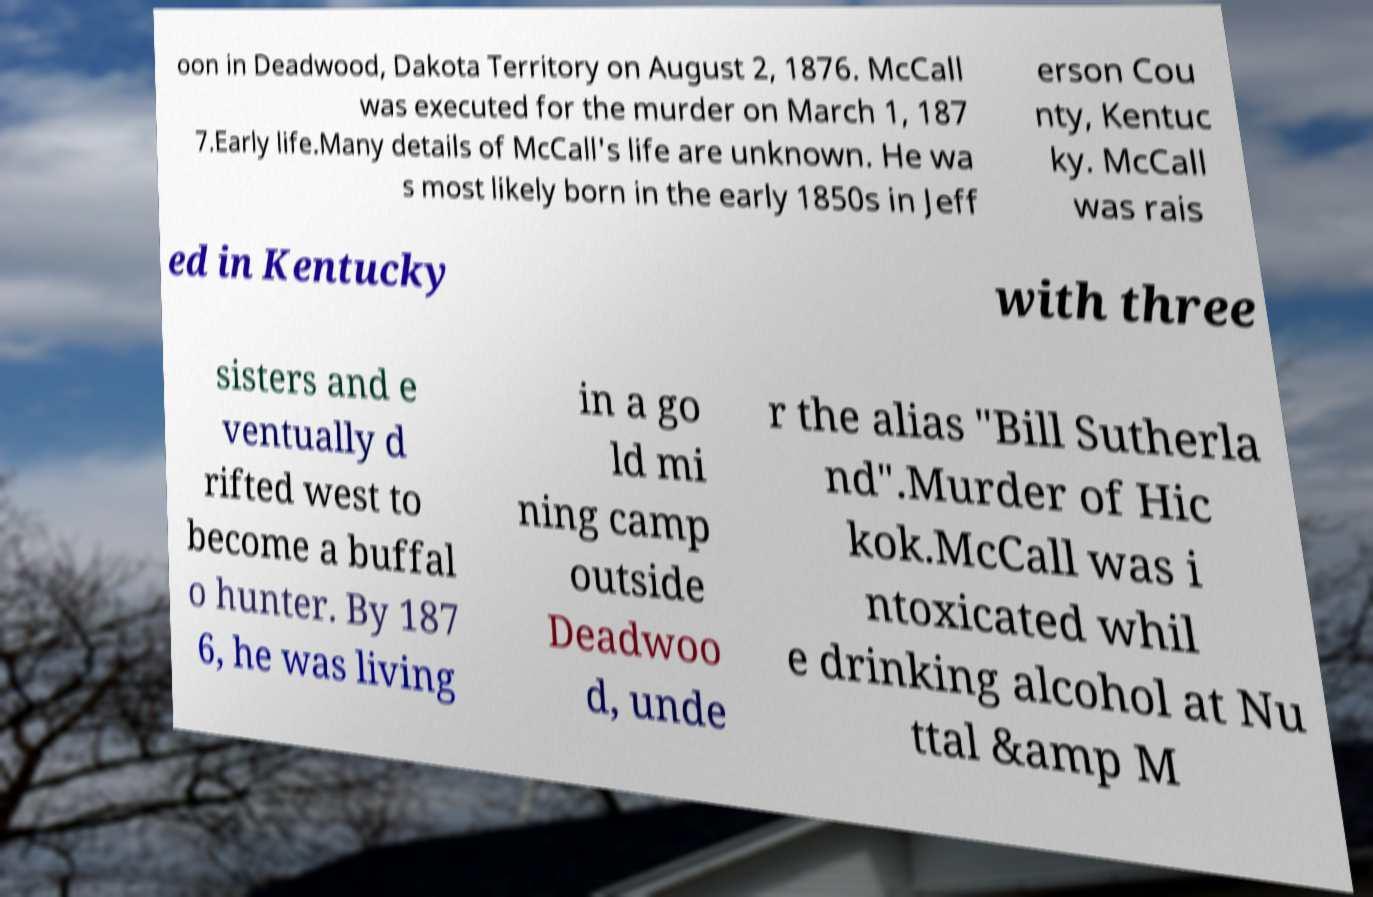For documentation purposes, I need the text within this image transcribed. Could you provide that? oon in Deadwood, Dakota Territory on August 2, 1876. McCall was executed for the murder on March 1, 187 7.Early life.Many details of McCall's life are unknown. He wa s most likely born in the early 1850s in Jeff erson Cou nty, Kentuc ky. McCall was rais ed in Kentucky with three sisters and e ventually d rifted west to become a buffal o hunter. By 187 6, he was living in a go ld mi ning camp outside Deadwoo d, unde r the alias "Bill Sutherla nd".Murder of Hic kok.McCall was i ntoxicated whil e drinking alcohol at Nu ttal &amp M 